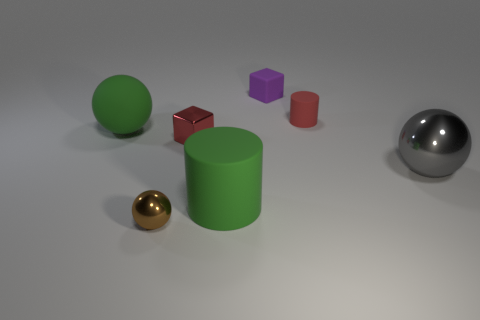Is there a gray object that has the same material as the tiny purple object?
Give a very brief answer. No. Does the big green cylinder have the same material as the small brown ball?
Provide a short and direct response. No. How many shiny objects are on the right side of the gray sphere behind the large matte cylinder?
Offer a terse response. 0. How many green objects are tiny rubber cylinders or big rubber cylinders?
Your response must be concise. 1. The large thing that is on the right side of the green rubber thing in front of the big sphere to the right of the green rubber cylinder is what shape?
Offer a very short reply. Sphere. What is the color of the matte sphere that is the same size as the green rubber cylinder?
Your response must be concise. Green. What number of brown objects are the same shape as the small purple thing?
Offer a terse response. 0. There is a brown thing; is its size the same as the sphere on the left side of the tiny brown shiny ball?
Provide a succinct answer. No. What shape is the large green object to the right of the cube that is left of the purple thing?
Offer a very short reply. Cylinder. Is the number of green matte cylinders behind the red cube less than the number of large yellow things?
Ensure brevity in your answer.  No. 